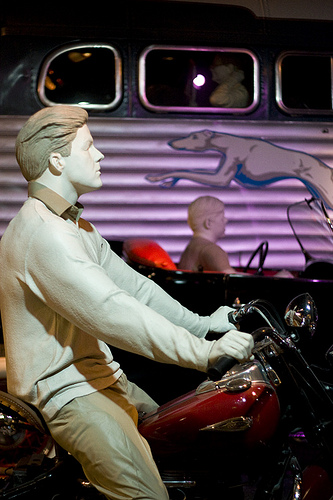<image>
Is the man on the motorcycle? Yes. Looking at the image, I can see the man is positioned on top of the motorcycle, with the motorcycle providing support. 